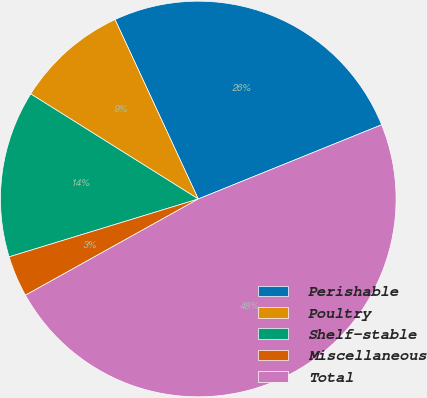Convert chart to OTSL. <chart><loc_0><loc_0><loc_500><loc_500><pie_chart><fcel>Perishable<fcel>Poultry<fcel>Shelf-stable<fcel>Miscellaneous<fcel>Total<nl><fcel>25.79%<fcel>9.17%<fcel>13.64%<fcel>3.36%<fcel>48.03%<nl></chart> 